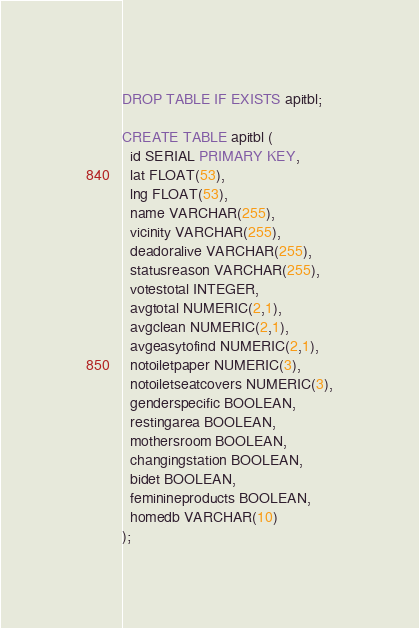<code> <loc_0><loc_0><loc_500><loc_500><_SQL_>
DROP TABLE IF EXISTS apitbl;

CREATE TABLE apitbl (
  id SERIAL PRIMARY KEY,
  lat FLOAT(53),
  lng FLOAT(53),
  name VARCHAR(255),
  vicinity VARCHAR(255),
  deadoralive VARCHAR(255),
  statusreason VARCHAR(255),
  votestotal INTEGER,
  avgtotal NUMERIC(2,1),
  avgclean NUMERIC(2,1),
  avgeasytofind NUMERIC(2,1),
  notoiletpaper NUMERIC(3),
  notoiletseatcovers NUMERIC(3),
  genderspecific BOOLEAN,
  restingarea BOOLEAN,
  mothersroom BOOLEAN,
  changingstation BOOLEAN,
  bidet BOOLEAN,
  feminineproducts BOOLEAN,
  homedb VARCHAR(10)
);
</code> 